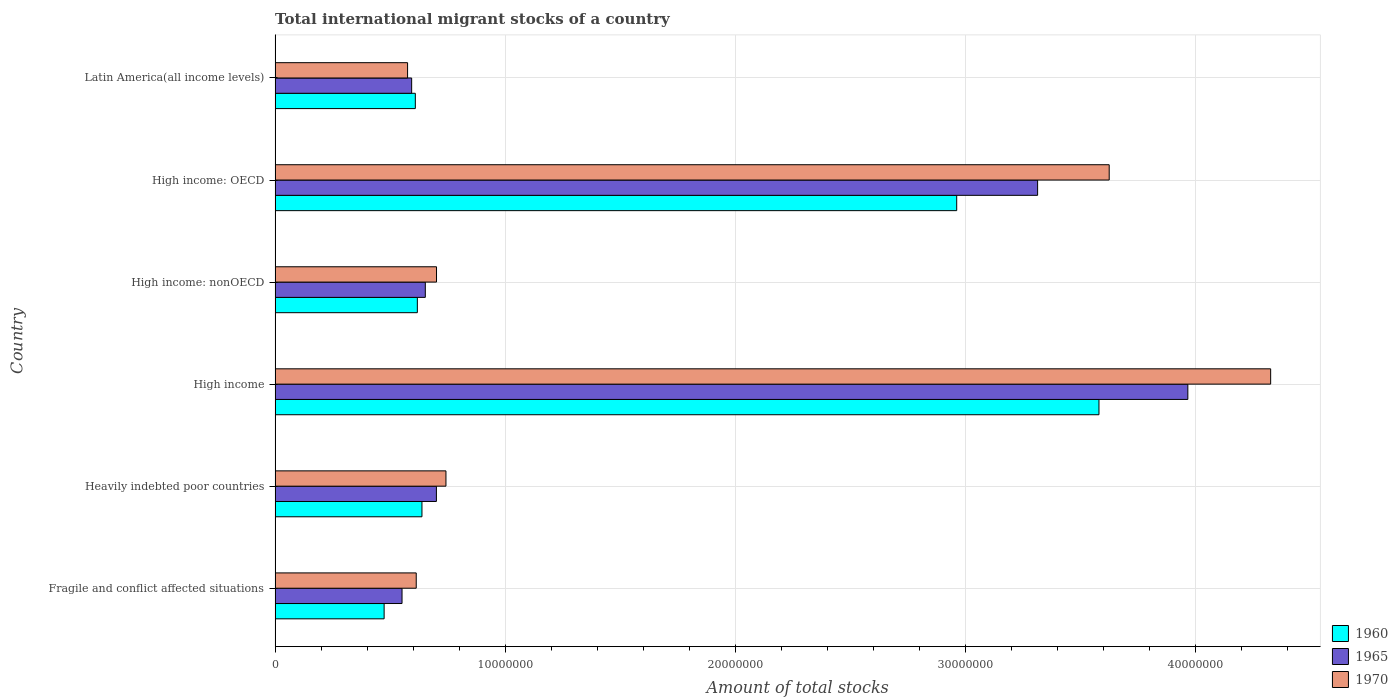How many different coloured bars are there?
Provide a short and direct response. 3. How many bars are there on the 5th tick from the top?
Provide a succinct answer. 3. How many bars are there on the 3rd tick from the bottom?
Ensure brevity in your answer.  3. What is the label of the 3rd group of bars from the top?
Give a very brief answer. High income: nonOECD. In how many cases, is the number of bars for a given country not equal to the number of legend labels?
Your answer should be very brief. 0. What is the amount of total stocks in in 1970 in Latin America(all income levels)?
Give a very brief answer. 5.76e+06. Across all countries, what is the maximum amount of total stocks in in 1965?
Offer a very short reply. 3.97e+07. Across all countries, what is the minimum amount of total stocks in in 1970?
Offer a terse response. 5.76e+06. In which country was the amount of total stocks in in 1970 minimum?
Give a very brief answer. Latin America(all income levels). What is the total amount of total stocks in in 1960 in the graph?
Offer a terse response. 8.89e+07. What is the difference between the amount of total stocks in in 1965 in High income: OECD and that in Latin America(all income levels)?
Offer a terse response. 2.72e+07. What is the difference between the amount of total stocks in in 1960 in High income: OECD and the amount of total stocks in in 1970 in Latin America(all income levels)?
Your answer should be very brief. 2.39e+07. What is the average amount of total stocks in in 1965 per country?
Your answer should be very brief. 1.63e+07. What is the difference between the amount of total stocks in in 1965 and amount of total stocks in in 1960 in High income?
Ensure brevity in your answer.  3.86e+06. What is the ratio of the amount of total stocks in in 1960 in Heavily indebted poor countries to that in High income: nonOECD?
Ensure brevity in your answer.  1.03. Is the amount of total stocks in in 1965 in Heavily indebted poor countries less than that in High income: nonOECD?
Make the answer very short. No. Is the difference between the amount of total stocks in in 1965 in High income: OECD and Latin America(all income levels) greater than the difference between the amount of total stocks in in 1960 in High income: OECD and Latin America(all income levels)?
Your answer should be very brief. Yes. What is the difference between the highest and the second highest amount of total stocks in in 1970?
Provide a succinct answer. 7.02e+06. What is the difference between the highest and the lowest amount of total stocks in in 1970?
Give a very brief answer. 3.75e+07. Is it the case that in every country, the sum of the amount of total stocks in in 1970 and amount of total stocks in in 1965 is greater than the amount of total stocks in in 1960?
Offer a very short reply. Yes. How many bars are there?
Offer a terse response. 18. How many countries are there in the graph?
Provide a succinct answer. 6. What is the difference between two consecutive major ticks on the X-axis?
Ensure brevity in your answer.  1.00e+07. How many legend labels are there?
Offer a very short reply. 3. How are the legend labels stacked?
Give a very brief answer. Vertical. What is the title of the graph?
Your answer should be compact. Total international migrant stocks of a country. What is the label or title of the X-axis?
Your answer should be compact. Amount of total stocks. What is the label or title of the Y-axis?
Offer a terse response. Country. What is the Amount of total stocks of 1960 in Fragile and conflict affected situations?
Provide a short and direct response. 4.74e+06. What is the Amount of total stocks of 1965 in Fragile and conflict affected situations?
Make the answer very short. 5.52e+06. What is the Amount of total stocks of 1970 in Fragile and conflict affected situations?
Provide a short and direct response. 6.14e+06. What is the Amount of total stocks of 1960 in Heavily indebted poor countries?
Make the answer very short. 6.38e+06. What is the Amount of total stocks in 1965 in Heavily indebted poor countries?
Provide a succinct answer. 7.01e+06. What is the Amount of total stocks in 1970 in Heavily indebted poor countries?
Offer a terse response. 7.43e+06. What is the Amount of total stocks in 1960 in High income?
Your answer should be compact. 3.58e+07. What is the Amount of total stocks in 1965 in High income?
Offer a very short reply. 3.97e+07. What is the Amount of total stocks of 1970 in High income?
Offer a very short reply. 4.33e+07. What is the Amount of total stocks in 1960 in High income: nonOECD?
Provide a short and direct response. 6.18e+06. What is the Amount of total stocks of 1965 in High income: nonOECD?
Provide a succinct answer. 6.53e+06. What is the Amount of total stocks in 1970 in High income: nonOECD?
Ensure brevity in your answer.  7.02e+06. What is the Amount of total stocks in 1960 in High income: OECD?
Provide a succinct answer. 2.96e+07. What is the Amount of total stocks of 1965 in High income: OECD?
Make the answer very short. 3.31e+07. What is the Amount of total stocks of 1970 in High income: OECD?
Give a very brief answer. 3.63e+07. What is the Amount of total stocks in 1960 in Latin America(all income levels)?
Keep it short and to the point. 6.10e+06. What is the Amount of total stocks of 1965 in Latin America(all income levels)?
Make the answer very short. 5.94e+06. What is the Amount of total stocks in 1970 in Latin America(all income levels)?
Ensure brevity in your answer.  5.76e+06. Across all countries, what is the maximum Amount of total stocks in 1960?
Offer a very short reply. 3.58e+07. Across all countries, what is the maximum Amount of total stocks of 1965?
Offer a terse response. 3.97e+07. Across all countries, what is the maximum Amount of total stocks of 1970?
Offer a very short reply. 4.33e+07. Across all countries, what is the minimum Amount of total stocks in 1960?
Offer a terse response. 4.74e+06. Across all countries, what is the minimum Amount of total stocks in 1965?
Offer a terse response. 5.52e+06. Across all countries, what is the minimum Amount of total stocks of 1970?
Ensure brevity in your answer.  5.76e+06. What is the total Amount of total stocks in 1960 in the graph?
Make the answer very short. 8.89e+07. What is the total Amount of total stocks in 1965 in the graph?
Make the answer very short. 9.78e+07. What is the total Amount of total stocks of 1970 in the graph?
Your answer should be compact. 1.06e+08. What is the difference between the Amount of total stocks in 1960 in Fragile and conflict affected situations and that in Heavily indebted poor countries?
Your response must be concise. -1.64e+06. What is the difference between the Amount of total stocks of 1965 in Fragile and conflict affected situations and that in Heavily indebted poor countries?
Ensure brevity in your answer.  -1.49e+06. What is the difference between the Amount of total stocks of 1970 in Fragile and conflict affected situations and that in Heavily indebted poor countries?
Make the answer very short. -1.29e+06. What is the difference between the Amount of total stocks of 1960 in Fragile and conflict affected situations and that in High income?
Your response must be concise. -3.11e+07. What is the difference between the Amount of total stocks of 1965 in Fragile and conflict affected situations and that in High income?
Give a very brief answer. -3.42e+07. What is the difference between the Amount of total stocks in 1970 in Fragile and conflict affected situations and that in High income?
Your response must be concise. -3.71e+07. What is the difference between the Amount of total stocks in 1960 in Fragile and conflict affected situations and that in High income: nonOECD?
Provide a succinct answer. -1.44e+06. What is the difference between the Amount of total stocks in 1965 in Fragile and conflict affected situations and that in High income: nonOECD?
Keep it short and to the point. -1.01e+06. What is the difference between the Amount of total stocks in 1970 in Fragile and conflict affected situations and that in High income: nonOECD?
Keep it short and to the point. -8.82e+05. What is the difference between the Amount of total stocks of 1960 in Fragile and conflict affected situations and that in High income: OECD?
Provide a succinct answer. -2.49e+07. What is the difference between the Amount of total stocks of 1965 in Fragile and conflict affected situations and that in High income: OECD?
Offer a terse response. -2.76e+07. What is the difference between the Amount of total stocks in 1970 in Fragile and conflict affected situations and that in High income: OECD?
Give a very brief answer. -3.01e+07. What is the difference between the Amount of total stocks in 1960 in Fragile and conflict affected situations and that in Latin America(all income levels)?
Your response must be concise. -1.36e+06. What is the difference between the Amount of total stocks of 1965 in Fragile and conflict affected situations and that in Latin America(all income levels)?
Your response must be concise. -4.18e+05. What is the difference between the Amount of total stocks in 1970 in Fragile and conflict affected situations and that in Latin America(all income levels)?
Give a very brief answer. 3.76e+05. What is the difference between the Amount of total stocks of 1960 in Heavily indebted poor countries and that in High income?
Offer a terse response. -2.94e+07. What is the difference between the Amount of total stocks in 1965 in Heavily indebted poor countries and that in High income?
Your answer should be compact. -3.27e+07. What is the difference between the Amount of total stocks of 1970 in Heavily indebted poor countries and that in High income?
Your answer should be very brief. -3.59e+07. What is the difference between the Amount of total stocks of 1960 in Heavily indebted poor countries and that in High income: nonOECD?
Provide a succinct answer. 2.00e+05. What is the difference between the Amount of total stocks of 1965 in Heavily indebted poor countries and that in High income: nonOECD?
Your answer should be compact. 4.82e+05. What is the difference between the Amount of total stocks in 1970 in Heavily indebted poor countries and that in High income: nonOECD?
Provide a short and direct response. 4.10e+05. What is the difference between the Amount of total stocks of 1960 in Heavily indebted poor countries and that in High income: OECD?
Give a very brief answer. -2.32e+07. What is the difference between the Amount of total stocks of 1965 in Heavily indebted poor countries and that in High income: OECD?
Provide a succinct answer. -2.61e+07. What is the difference between the Amount of total stocks in 1970 in Heavily indebted poor countries and that in High income: OECD?
Your answer should be very brief. -2.88e+07. What is the difference between the Amount of total stocks of 1960 in Heavily indebted poor countries and that in Latin America(all income levels)?
Your answer should be compact. 2.88e+05. What is the difference between the Amount of total stocks of 1965 in Heavily indebted poor countries and that in Latin America(all income levels)?
Make the answer very short. 1.08e+06. What is the difference between the Amount of total stocks in 1970 in Heavily indebted poor countries and that in Latin America(all income levels)?
Provide a succinct answer. 1.67e+06. What is the difference between the Amount of total stocks of 1960 in High income and that in High income: nonOECD?
Give a very brief answer. 2.96e+07. What is the difference between the Amount of total stocks in 1965 in High income and that in High income: nonOECD?
Make the answer very short. 3.31e+07. What is the difference between the Amount of total stocks in 1970 in High income and that in High income: nonOECD?
Make the answer very short. 3.63e+07. What is the difference between the Amount of total stocks of 1960 in High income and that in High income: OECD?
Make the answer very short. 6.18e+06. What is the difference between the Amount of total stocks in 1965 in High income and that in High income: OECD?
Provide a short and direct response. 6.53e+06. What is the difference between the Amount of total stocks in 1970 in High income and that in High income: OECD?
Provide a succinct answer. 7.02e+06. What is the difference between the Amount of total stocks in 1960 in High income and that in Latin America(all income levels)?
Give a very brief answer. 2.97e+07. What is the difference between the Amount of total stocks of 1965 in High income and that in Latin America(all income levels)?
Give a very brief answer. 3.37e+07. What is the difference between the Amount of total stocks in 1970 in High income and that in Latin America(all income levels)?
Provide a short and direct response. 3.75e+07. What is the difference between the Amount of total stocks of 1960 in High income: nonOECD and that in High income: OECD?
Your answer should be compact. -2.34e+07. What is the difference between the Amount of total stocks of 1965 in High income: nonOECD and that in High income: OECD?
Offer a terse response. -2.66e+07. What is the difference between the Amount of total stocks of 1970 in High income: nonOECD and that in High income: OECD?
Your response must be concise. -2.92e+07. What is the difference between the Amount of total stocks in 1960 in High income: nonOECD and that in Latin America(all income levels)?
Ensure brevity in your answer.  8.75e+04. What is the difference between the Amount of total stocks in 1965 in High income: nonOECD and that in Latin America(all income levels)?
Provide a short and direct response. 5.94e+05. What is the difference between the Amount of total stocks in 1970 in High income: nonOECD and that in Latin America(all income levels)?
Offer a very short reply. 1.26e+06. What is the difference between the Amount of total stocks in 1960 in High income: OECD and that in Latin America(all income levels)?
Your answer should be compact. 2.35e+07. What is the difference between the Amount of total stocks in 1965 in High income: OECD and that in Latin America(all income levels)?
Provide a succinct answer. 2.72e+07. What is the difference between the Amount of total stocks of 1970 in High income: OECD and that in Latin America(all income levels)?
Offer a very short reply. 3.05e+07. What is the difference between the Amount of total stocks in 1960 in Fragile and conflict affected situations and the Amount of total stocks in 1965 in Heavily indebted poor countries?
Provide a succinct answer. -2.27e+06. What is the difference between the Amount of total stocks of 1960 in Fragile and conflict affected situations and the Amount of total stocks of 1970 in Heavily indebted poor countries?
Offer a terse response. -2.69e+06. What is the difference between the Amount of total stocks of 1965 in Fragile and conflict affected situations and the Amount of total stocks of 1970 in Heavily indebted poor countries?
Keep it short and to the point. -1.91e+06. What is the difference between the Amount of total stocks in 1960 in Fragile and conflict affected situations and the Amount of total stocks in 1965 in High income?
Keep it short and to the point. -3.49e+07. What is the difference between the Amount of total stocks in 1960 in Fragile and conflict affected situations and the Amount of total stocks in 1970 in High income?
Your response must be concise. -3.85e+07. What is the difference between the Amount of total stocks of 1965 in Fragile and conflict affected situations and the Amount of total stocks of 1970 in High income?
Keep it short and to the point. -3.78e+07. What is the difference between the Amount of total stocks in 1960 in Fragile and conflict affected situations and the Amount of total stocks in 1965 in High income: nonOECD?
Provide a succinct answer. -1.79e+06. What is the difference between the Amount of total stocks in 1960 in Fragile and conflict affected situations and the Amount of total stocks in 1970 in High income: nonOECD?
Offer a very short reply. -2.28e+06. What is the difference between the Amount of total stocks of 1965 in Fragile and conflict affected situations and the Amount of total stocks of 1970 in High income: nonOECD?
Your response must be concise. -1.50e+06. What is the difference between the Amount of total stocks in 1960 in Fragile and conflict affected situations and the Amount of total stocks in 1965 in High income: OECD?
Your response must be concise. -2.84e+07. What is the difference between the Amount of total stocks in 1960 in Fragile and conflict affected situations and the Amount of total stocks in 1970 in High income: OECD?
Your answer should be very brief. -3.15e+07. What is the difference between the Amount of total stocks of 1965 in Fragile and conflict affected situations and the Amount of total stocks of 1970 in High income: OECD?
Your answer should be compact. -3.07e+07. What is the difference between the Amount of total stocks of 1960 in Fragile and conflict affected situations and the Amount of total stocks of 1965 in Latin America(all income levels)?
Your response must be concise. -1.20e+06. What is the difference between the Amount of total stocks of 1960 in Fragile and conflict affected situations and the Amount of total stocks of 1970 in Latin America(all income levels)?
Your answer should be very brief. -1.02e+06. What is the difference between the Amount of total stocks of 1965 in Fragile and conflict affected situations and the Amount of total stocks of 1970 in Latin America(all income levels)?
Keep it short and to the point. -2.41e+05. What is the difference between the Amount of total stocks in 1960 in Heavily indebted poor countries and the Amount of total stocks in 1965 in High income?
Make the answer very short. -3.33e+07. What is the difference between the Amount of total stocks of 1960 in Heavily indebted poor countries and the Amount of total stocks of 1970 in High income?
Make the answer very short. -3.69e+07. What is the difference between the Amount of total stocks of 1965 in Heavily indebted poor countries and the Amount of total stocks of 1970 in High income?
Your response must be concise. -3.63e+07. What is the difference between the Amount of total stocks in 1960 in Heavily indebted poor countries and the Amount of total stocks in 1965 in High income: nonOECD?
Your response must be concise. -1.46e+05. What is the difference between the Amount of total stocks of 1960 in Heavily indebted poor countries and the Amount of total stocks of 1970 in High income: nonOECD?
Give a very brief answer. -6.34e+05. What is the difference between the Amount of total stocks in 1965 in Heavily indebted poor countries and the Amount of total stocks in 1970 in High income: nonOECD?
Offer a terse response. -5219. What is the difference between the Amount of total stocks of 1960 in Heavily indebted poor countries and the Amount of total stocks of 1965 in High income: OECD?
Provide a succinct answer. -2.68e+07. What is the difference between the Amount of total stocks of 1960 in Heavily indebted poor countries and the Amount of total stocks of 1970 in High income: OECD?
Your response must be concise. -2.99e+07. What is the difference between the Amount of total stocks in 1965 in Heavily indebted poor countries and the Amount of total stocks in 1970 in High income: OECD?
Your response must be concise. -2.92e+07. What is the difference between the Amount of total stocks in 1960 in Heavily indebted poor countries and the Amount of total stocks in 1965 in Latin America(all income levels)?
Make the answer very short. 4.47e+05. What is the difference between the Amount of total stocks in 1960 in Heavily indebted poor countries and the Amount of total stocks in 1970 in Latin America(all income levels)?
Your answer should be compact. 6.25e+05. What is the difference between the Amount of total stocks in 1965 in Heavily indebted poor countries and the Amount of total stocks in 1970 in Latin America(all income levels)?
Offer a very short reply. 1.25e+06. What is the difference between the Amount of total stocks in 1960 in High income and the Amount of total stocks in 1965 in High income: nonOECD?
Keep it short and to the point. 2.93e+07. What is the difference between the Amount of total stocks of 1960 in High income and the Amount of total stocks of 1970 in High income: nonOECD?
Keep it short and to the point. 2.88e+07. What is the difference between the Amount of total stocks in 1965 in High income and the Amount of total stocks in 1970 in High income: nonOECD?
Ensure brevity in your answer.  3.27e+07. What is the difference between the Amount of total stocks of 1960 in High income and the Amount of total stocks of 1965 in High income: OECD?
Your response must be concise. 2.67e+06. What is the difference between the Amount of total stocks in 1960 in High income and the Amount of total stocks in 1970 in High income: OECD?
Provide a succinct answer. -4.45e+05. What is the difference between the Amount of total stocks of 1965 in High income and the Amount of total stocks of 1970 in High income: OECD?
Your answer should be very brief. 3.42e+06. What is the difference between the Amount of total stocks in 1960 in High income and the Amount of total stocks in 1965 in Latin America(all income levels)?
Ensure brevity in your answer.  2.99e+07. What is the difference between the Amount of total stocks of 1960 in High income and the Amount of total stocks of 1970 in Latin America(all income levels)?
Provide a short and direct response. 3.01e+07. What is the difference between the Amount of total stocks of 1965 in High income and the Amount of total stocks of 1970 in Latin America(all income levels)?
Offer a terse response. 3.39e+07. What is the difference between the Amount of total stocks in 1960 in High income: nonOECD and the Amount of total stocks in 1965 in High income: OECD?
Provide a succinct answer. -2.70e+07. What is the difference between the Amount of total stocks in 1960 in High income: nonOECD and the Amount of total stocks in 1970 in High income: OECD?
Provide a short and direct response. -3.01e+07. What is the difference between the Amount of total stocks of 1965 in High income: nonOECD and the Amount of total stocks of 1970 in High income: OECD?
Provide a succinct answer. -2.97e+07. What is the difference between the Amount of total stocks in 1960 in High income: nonOECD and the Amount of total stocks in 1965 in Latin America(all income levels)?
Your response must be concise. 2.47e+05. What is the difference between the Amount of total stocks in 1960 in High income: nonOECD and the Amount of total stocks in 1970 in Latin America(all income levels)?
Offer a terse response. 4.25e+05. What is the difference between the Amount of total stocks in 1965 in High income: nonOECD and the Amount of total stocks in 1970 in Latin America(all income levels)?
Make the answer very short. 7.71e+05. What is the difference between the Amount of total stocks of 1960 in High income: OECD and the Amount of total stocks of 1965 in Latin America(all income levels)?
Your answer should be compact. 2.37e+07. What is the difference between the Amount of total stocks of 1960 in High income: OECD and the Amount of total stocks of 1970 in Latin America(all income levels)?
Provide a short and direct response. 2.39e+07. What is the difference between the Amount of total stocks of 1965 in High income: OECD and the Amount of total stocks of 1970 in Latin America(all income levels)?
Provide a short and direct response. 2.74e+07. What is the average Amount of total stocks of 1960 per country?
Your answer should be compact. 1.48e+07. What is the average Amount of total stocks of 1965 per country?
Ensure brevity in your answer.  1.63e+07. What is the average Amount of total stocks in 1970 per country?
Give a very brief answer. 1.76e+07. What is the difference between the Amount of total stocks in 1960 and Amount of total stocks in 1965 in Fragile and conflict affected situations?
Your response must be concise. -7.79e+05. What is the difference between the Amount of total stocks of 1960 and Amount of total stocks of 1970 in Fragile and conflict affected situations?
Your answer should be very brief. -1.40e+06. What is the difference between the Amount of total stocks in 1965 and Amount of total stocks in 1970 in Fragile and conflict affected situations?
Provide a short and direct response. -6.17e+05. What is the difference between the Amount of total stocks in 1960 and Amount of total stocks in 1965 in Heavily indebted poor countries?
Provide a short and direct response. -6.28e+05. What is the difference between the Amount of total stocks in 1960 and Amount of total stocks in 1970 in Heavily indebted poor countries?
Provide a succinct answer. -1.04e+06. What is the difference between the Amount of total stocks of 1965 and Amount of total stocks of 1970 in Heavily indebted poor countries?
Keep it short and to the point. -4.15e+05. What is the difference between the Amount of total stocks of 1960 and Amount of total stocks of 1965 in High income?
Keep it short and to the point. -3.86e+06. What is the difference between the Amount of total stocks in 1960 and Amount of total stocks in 1970 in High income?
Your answer should be compact. -7.46e+06. What is the difference between the Amount of total stocks of 1965 and Amount of total stocks of 1970 in High income?
Provide a succinct answer. -3.60e+06. What is the difference between the Amount of total stocks of 1960 and Amount of total stocks of 1965 in High income: nonOECD?
Give a very brief answer. -3.47e+05. What is the difference between the Amount of total stocks in 1960 and Amount of total stocks in 1970 in High income: nonOECD?
Your answer should be compact. -8.34e+05. What is the difference between the Amount of total stocks of 1965 and Amount of total stocks of 1970 in High income: nonOECD?
Provide a short and direct response. -4.87e+05. What is the difference between the Amount of total stocks of 1960 and Amount of total stocks of 1965 in High income: OECD?
Offer a terse response. -3.52e+06. What is the difference between the Amount of total stocks in 1960 and Amount of total stocks in 1970 in High income: OECD?
Your response must be concise. -6.63e+06. What is the difference between the Amount of total stocks of 1965 and Amount of total stocks of 1970 in High income: OECD?
Offer a very short reply. -3.11e+06. What is the difference between the Amount of total stocks in 1960 and Amount of total stocks in 1965 in Latin America(all income levels)?
Make the answer very short. 1.60e+05. What is the difference between the Amount of total stocks of 1960 and Amount of total stocks of 1970 in Latin America(all income levels)?
Give a very brief answer. 3.37e+05. What is the difference between the Amount of total stocks of 1965 and Amount of total stocks of 1970 in Latin America(all income levels)?
Keep it short and to the point. 1.77e+05. What is the ratio of the Amount of total stocks in 1960 in Fragile and conflict affected situations to that in Heavily indebted poor countries?
Make the answer very short. 0.74. What is the ratio of the Amount of total stocks of 1965 in Fragile and conflict affected situations to that in Heavily indebted poor countries?
Provide a succinct answer. 0.79. What is the ratio of the Amount of total stocks in 1970 in Fragile and conflict affected situations to that in Heavily indebted poor countries?
Offer a terse response. 0.83. What is the ratio of the Amount of total stocks in 1960 in Fragile and conflict affected situations to that in High income?
Provide a short and direct response. 0.13. What is the ratio of the Amount of total stocks in 1965 in Fragile and conflict affected situations to that in High income?
Make the answer very short. 0.14. What is the ratio of the Amount of total stocks of 1970 in Fragile and conflict affected situations to that in High income?
Give a very brief answer. 0.14. What is the ratio of the Amount of total stocks in 1960 in Fragile and conflict affected situations to that in High income: nonOECD?
Offer a terse response. 0.77. What is the ratio of the Amount of total stocks in 1965 in Fragile and conflict affected situations to that in High income: nonOECD?
Your response must be concise. 0.84. What is the ratio of the Amount of total stocks in 1970 in Fragile and conflict affected situations to that in High income: nonOECD?
Provide a short and direct response. 0.87. What is the ratio of the Amount of total stocks in 1960 in Fragile and conflict affected situations to that in High income: OECD?
Your response must be concise. 0.16. What is the ratio of the Amount of total stocks of 1965 in Fragile and conflict affected situations to that in High income: OECD?
Give a very brief answer. 0.17. What is the ratio of the Amount of total stocks of 1970 in Fragile and conflict affected situations to that in High income: OECD?
Give a very brief answer. 0.17. What is the ratio of the Amount of total stocks of 1960 in Fragile and conflict affected situations to that in Latin America(all income levels)?
Your answer should be compact. 0.78. What is the ratio of the Amount of total stocks in 1965 in Fragile and conflict affected situations to that in Latin America(all income levels)?
Provide a succinct answer. 0.93. What is the ratio of the Amount of total stocks in 1970 in Fragile and conflict affected situations to that in Latin America(all income levels)?
Make the answer very short. 1.07. What is the ratio of the Amount of total stocks in 1960 in Heavily indebted poor countries to that in High income?
Keep it short and to the point. 0.18. What is the ratio of the Amount of total stocks in 1965 in Heavily indebted poor countries to that in High income?
Your answer should be compact. 0.18. What is the ratio of the Amount of total stocks in 1970 in Heavily indebted poor countries to that in High income?
Offer a very short reply. 0.17. What is the ratio of the Amount of total stocks in 1960 in Heavily indebted poor countries to that in High income: nonOECD?
Offer a terse response. 1.03. What is the ratio of the Amount of total stocks of 1965 in Heavily indebted poor countries to that in High income: nonOECD?
Keep it short and to the point. 1.07. What is the ratio of the Amount of total stocks of 1970 in Heavily indebted poor countries to that in High income: nonOECD?
Ensure brevity in your answer.  1.06. What is the ratio of the Amount of total stocks of 1960 in Heavily indebted poor countries to that in High income: OECD?
Give a very brief answer. 0.22. What is the ratio of the Amount of total stocks in 1965 in Heavily indebted poor countries to that in High income: OECD?
Keep it short and to the point. 0.21. What is the ratio of the Amount of total stocks of 1970 in Heavily indebted poor countries to that in High income: OECD?
Ensure brevity in your answer.  0.2. What is the ratio of the Amount of total stocks of 1960 in Heavily indebted poor countries to that in Latin America(all income levels)?
Offer a terse response. 1.05. What is the ratio of the Amount of total stocks in 1965 in Heavily indebted poor countries to that in Latin America(all income levels)?
Provide a succinct answer. 1.18. What is the ratio of the Amount of total stocks in 1970 in Heavily indebted poor countries to that in Latin America(all income levels)?
Offer a terse response. 1.29. What is the ratio of the Amount of total stocks in 1960 in High income to that in High income: nonOECD?
Provide a short and direct response. 5.79. What is the ratio of the Amount of total stocks of 1965 in High income to that in High income: nonOECD?
Offer a terse response. 6.08. What is the ratio of the Amount of total stocks in 1970 in High income to that in High income: nonOECD?
Keep it short and to the point. 6.17. What is the ratio of the Amount of total stocks of 1960 in High income to that in High income: OECD?
Provide a short and direct response. 1.21. What is the ratio of the Amount of total stocks in 1965 in High income to that in High income: OECD?
Your response must be concise. 1.2. What is the ratio of the Amount of total stocks of 1970 in High income to that in High income: OECD?
Your answer should be compact. 1.19. What is the ratio of the Amount of total stocks in 1960 in High income to that in Latin America(all income levels)?
Offer a terse response. 5.87. What is the ratio of the Amount of total stocks in 1965 in High income to that in Latin America(all income levels)?
Offer a terse response. 6.68. What is the ratio of the Amount of total stocks of 1970 in High income to that in Latin America(all income levels)?
Provide a succinct answer. 7.51. What is the ratio of the Amount of total stocks of 1960 in High income: nonOECD to that in High income: OECD?
Provide a succinct answer. 0.21. What is the ratio of the Amount of total stocks in 1965 in High income: nonOECD to that in High income: OECD?
Make the answer very short. 0.2. What is the ratio of the Amount of total stocks of 1970 in High income: nonOECD to that in High income: OECD?
Offer a terse response. 0.19. What is the ratio of the Amount of total stocks in 1960 in High income: nonOECD to that in Latin America(all income levels)?
Your response must be concise. 1.01. What is the ratio of the Amount of total stocks in 1970 in High income: nonOECD to that in Latin America(all income levels)?
Provide a short and direct response. 1.22. What is the ratio of the Amount of total stocks in 1960 in High income: OECD to that in Latin America(all income levels)?
Ensure brevity in your answer.  4.86. What is the ratio of the Amount of total stocks in 1965 in High income: OECD to that in Latin America(all income levels)?
Your response must be concise. 5.58. What is the ratio of the Amount of total stocks of 1970 in High income: OECD to that in Latin America(all income levels)?
Your response must be concise. 6.3. What is the difference between the highest and the second highest Amount of total stocks in 1960?
Make the answer very short. 6.18e+06. What is the difference between the highest and the second highest Amount of total stocks of 1965?
Your answer should be compact. 6.53e+06. What is the difference between the highest and the second highest Amount of total stocks of 1970?
Provide a short and direct response. 7.02e+06. What is the difference between the highest and the lowest Amount of total stocks of 1960?
Your answer should be compact. 3.11e+07. What is the difference between the highest and the lowest Amount of total stocks in 1965?
Your response must be concise. 3.42e+07. What is the difference between the highest and the lowest Amount of total stocks of 1970?
Provide a succinct answer. 3.75e+07. 